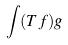Convert formula to latex. <formula><loc_0><loc_0><loc_500><loc_500>\int ( T f ) g</formula> 